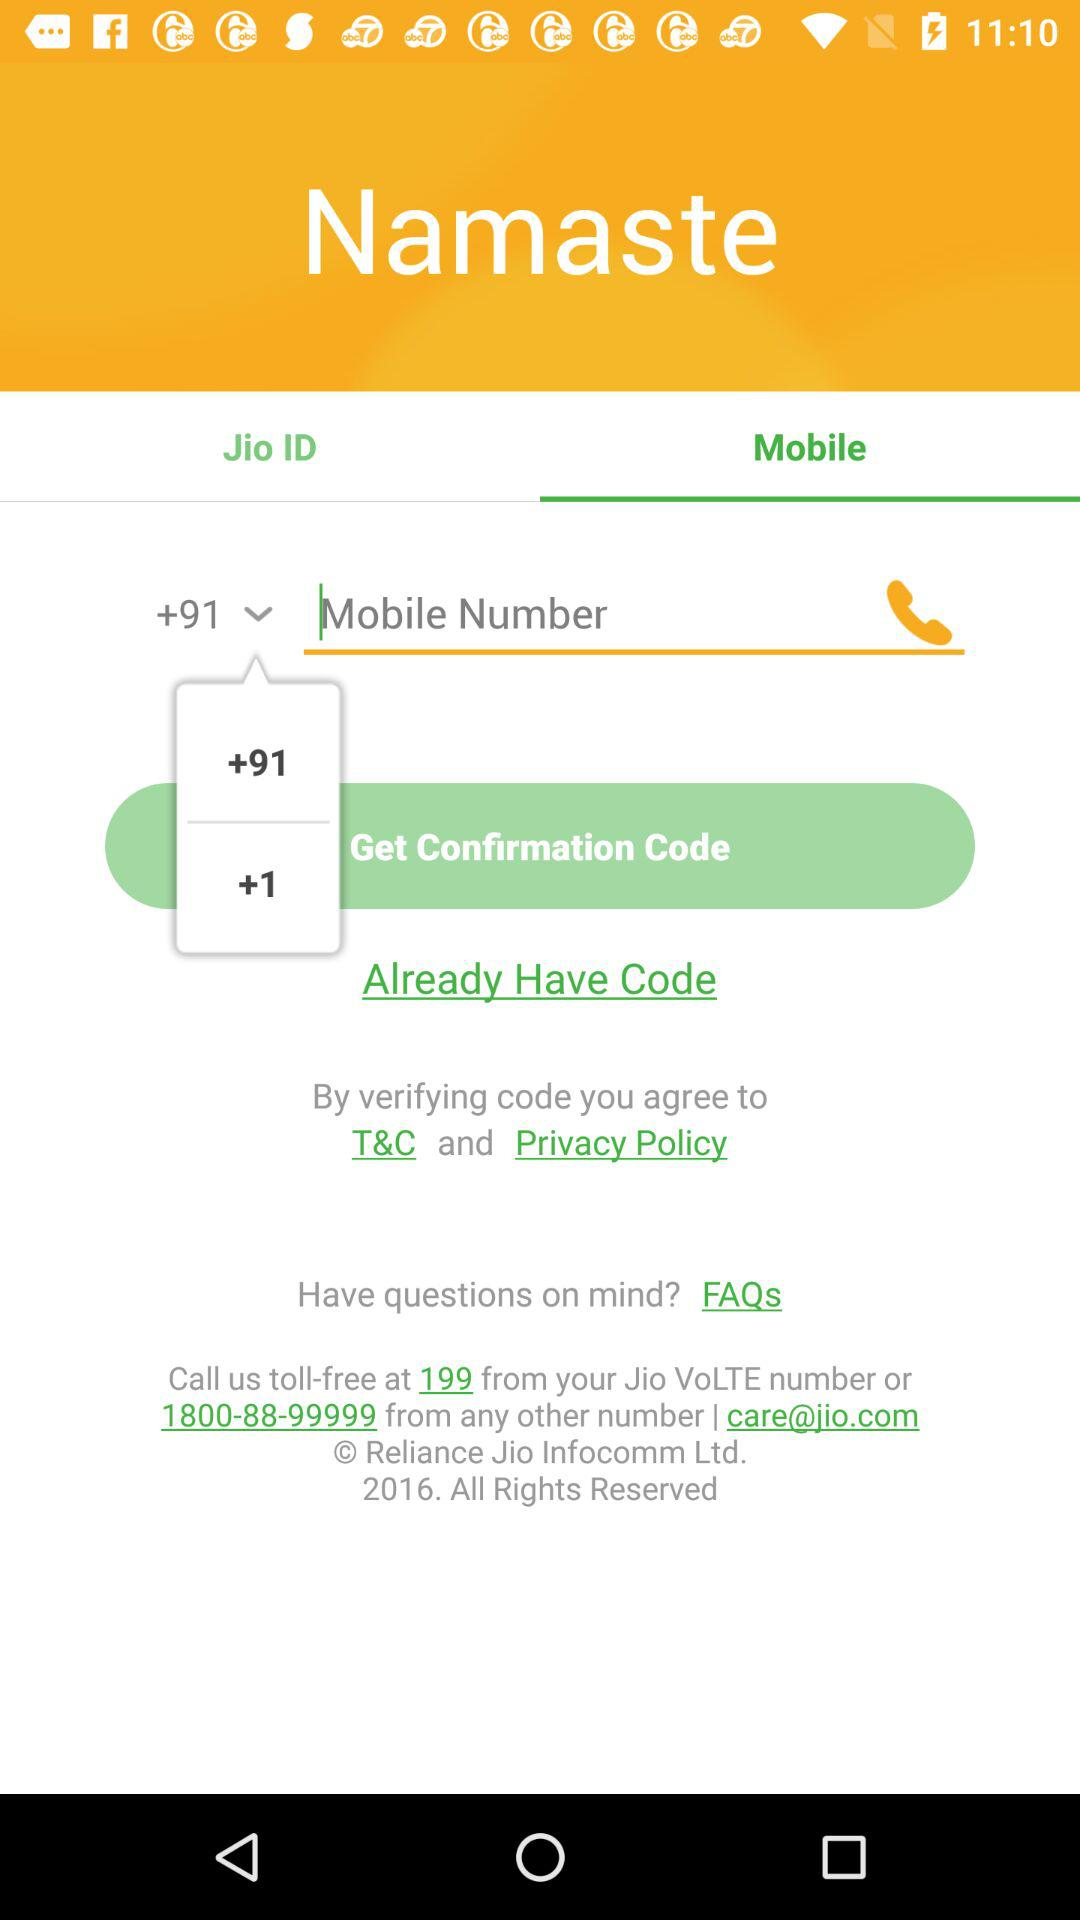What is the application name? The application name is "Namaste". 